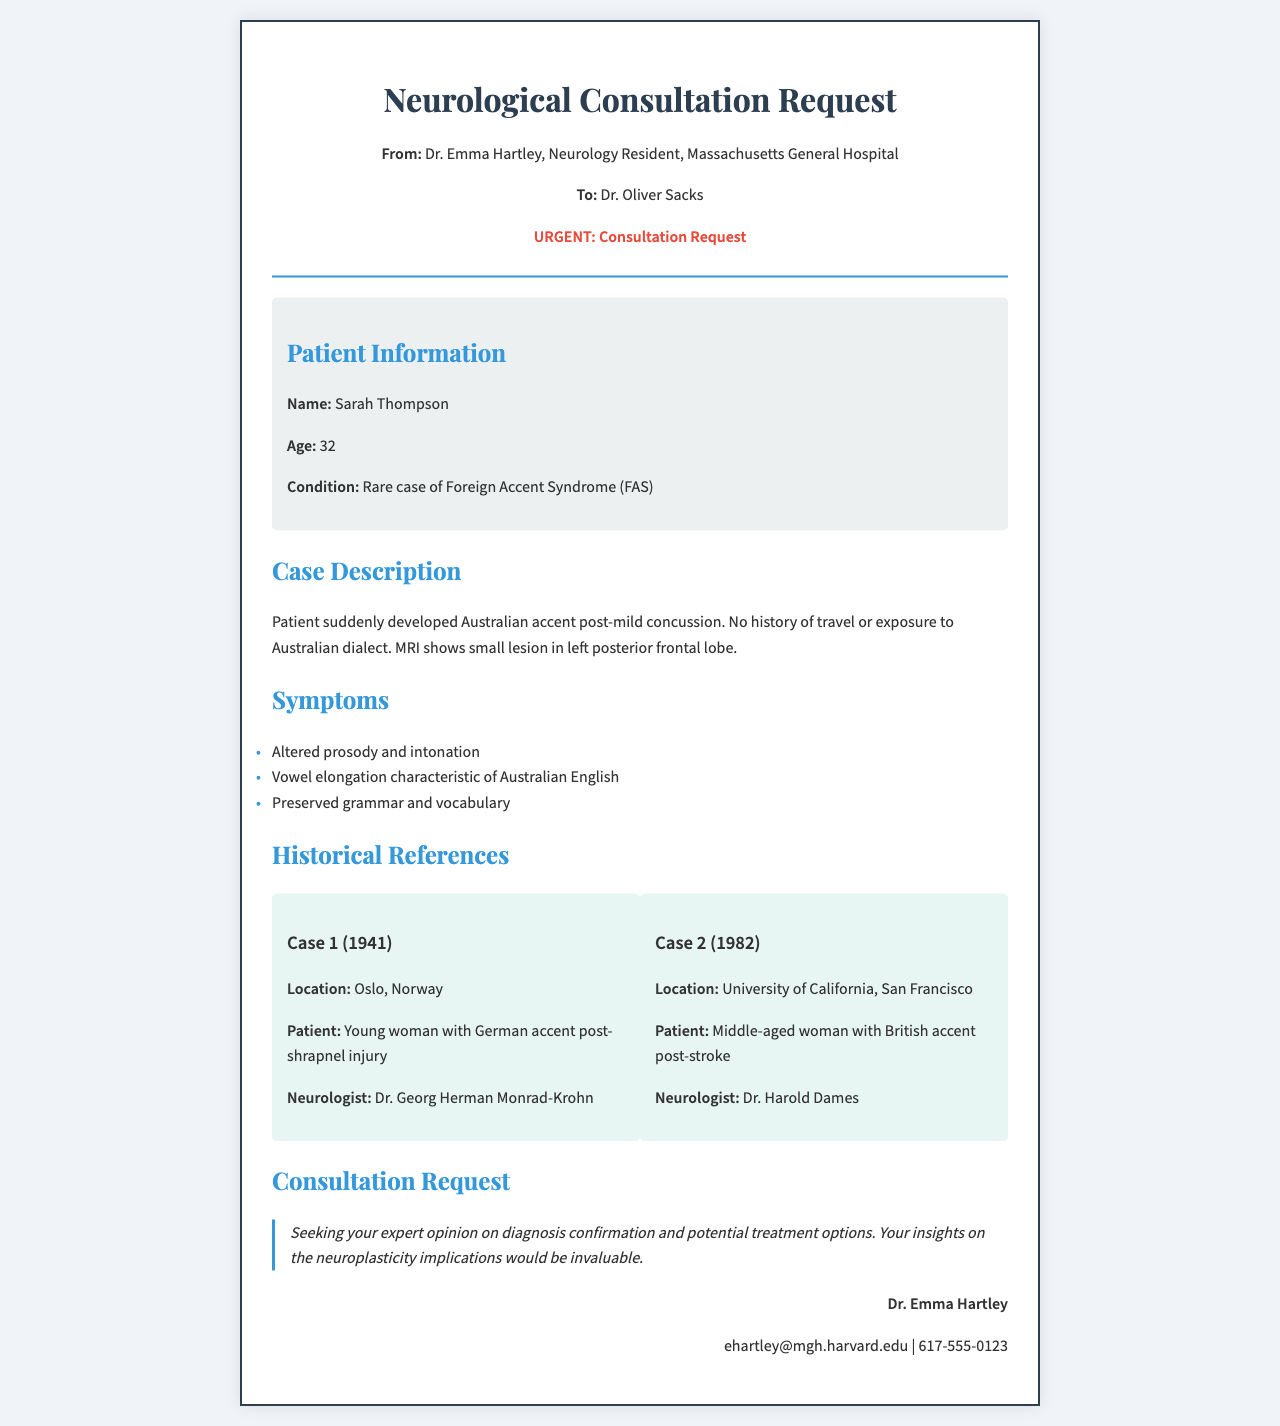what is the patient's name? The patient's name is provided in the patient information section of the document.
Answer: Sarah Thompson what is the age of the patient? The document specifies the patient's age in the patient information section.
Answer: 32 what neurological condition is the patient experiencing? The condition is mentioned directly in the patient information section.
Answer: Foreign Accent Syndrome who is the neurologist addressed in the consultation request? The neurologist's name is included in the header of the fax.
Answer: Dr. Oliver Sacks what was noted in the MRI results? The MRI results are summarized in the case description of the document.
Answer: Small lesion in left posterior frontal lobe when did Case 1 occur? The date of the historical case is provided in the description of Case 1.
Answer: 1941 what accent did the patient exhibit post-concussion? The specific change in accent is detailed in the case description.
Answer: Australian accent what is the main consultation request? The primary focus of the consultation request is summarized in the consultation request section.
Answer: Diagnosis confirmation and potential treatment options which historical neurologist is mentioned with Case 2? The neurologist's name is specifically mentioned in the description of Case 2.
Answer: Dr. Harold Dames 